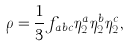Convert formula to latex. <formula><loc_0><loc_0><loc_500><loc_500>\rho = \frac { 1 } { 3 } f _ { a b c } \eta _ { 2 } ^ { a } \eta _ { 2 } ^ { b } \eta _ { 2 } ^ { c } ,</formula> 